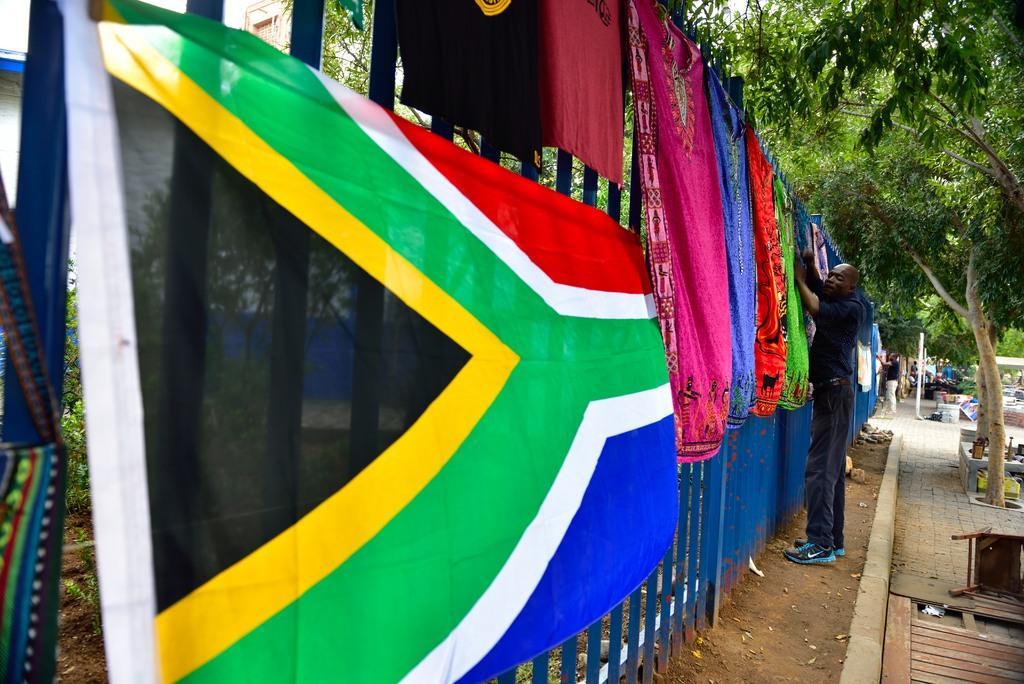In one or two sentences, can you explain what this image depicts? In this image there is a Fencing wall as we can see in the middle of this image. In this image there are some clothes are hanging on to this wall. There are some trees on the right side of this image. There are some persons standing on the right side of this image. 